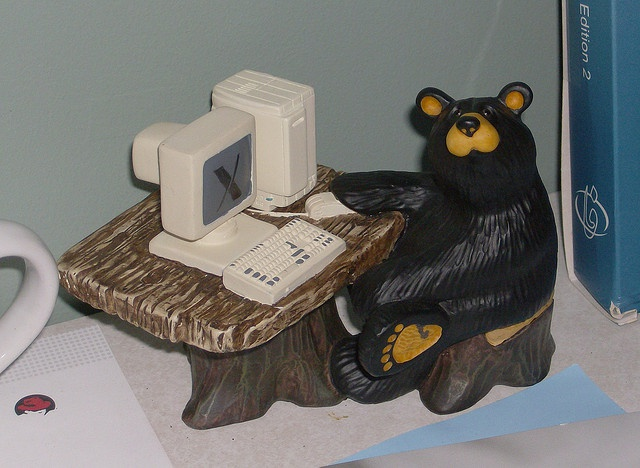Describe the objects in this image and their specific colors. I can see teddy bear in gray, black, and olive tones, book in gray, blue, darkblue, and navy tones, tv in gray, darkgray, tan, and black tones, keyboard in gray, darkgray, and tan tones, and mouse in gray, darkgray, tan, and lightgray tones in this image. 